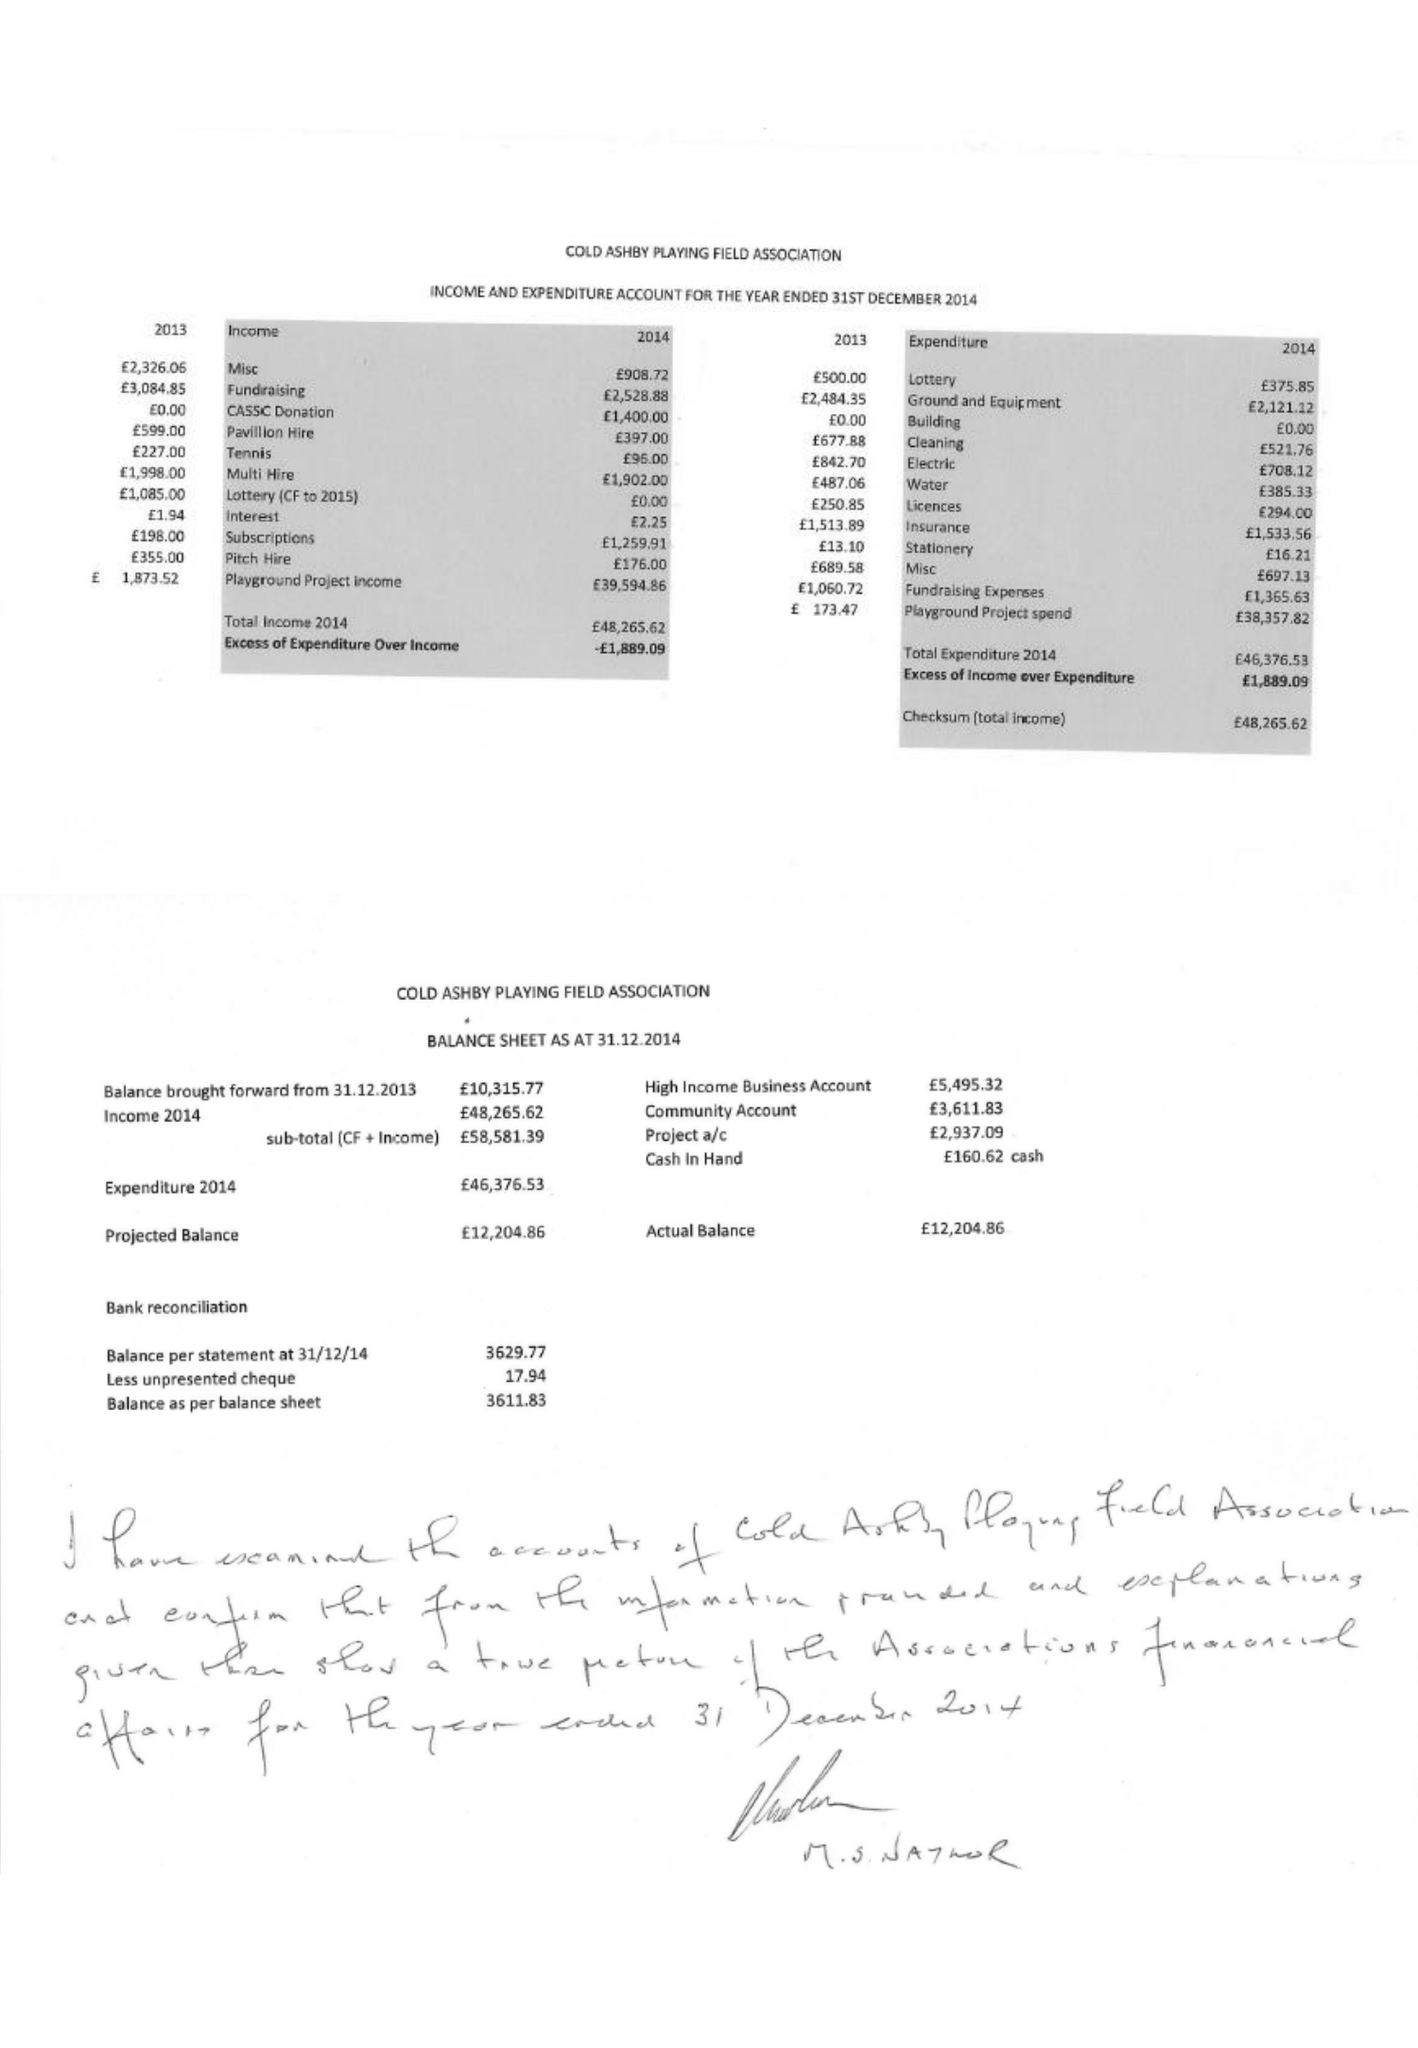What is the value for the report_date?
Answer the question using a single word or phrase. 2014-12-31 